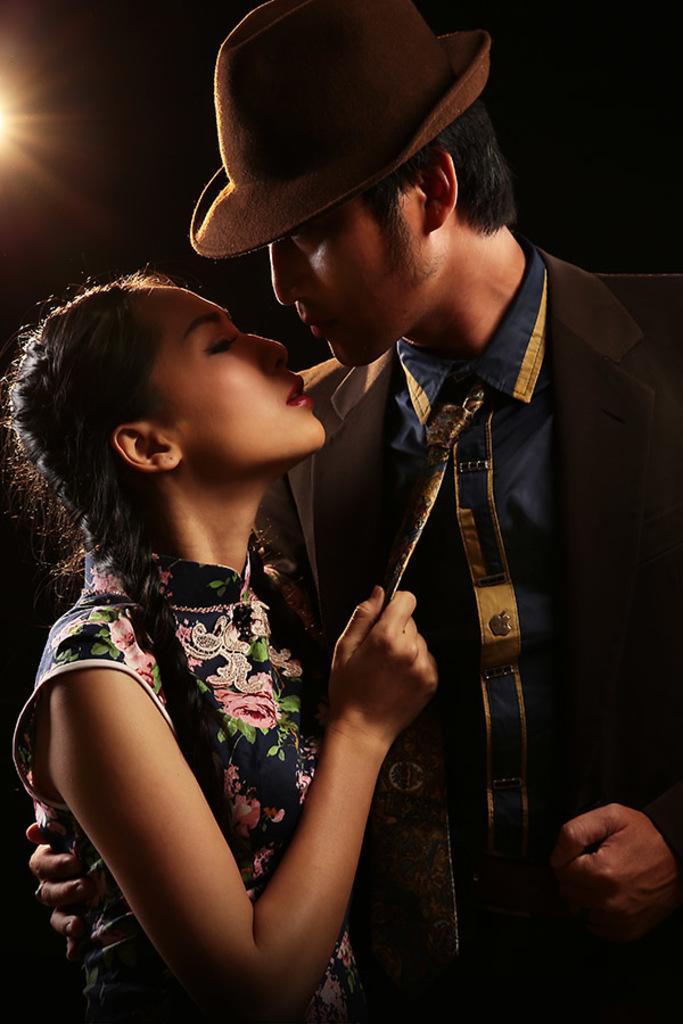In one or two sentences, can you explain what this image depicts? In this image, we can see persons wearing clothes. There is a person on the right side of the image wearing a hat. 